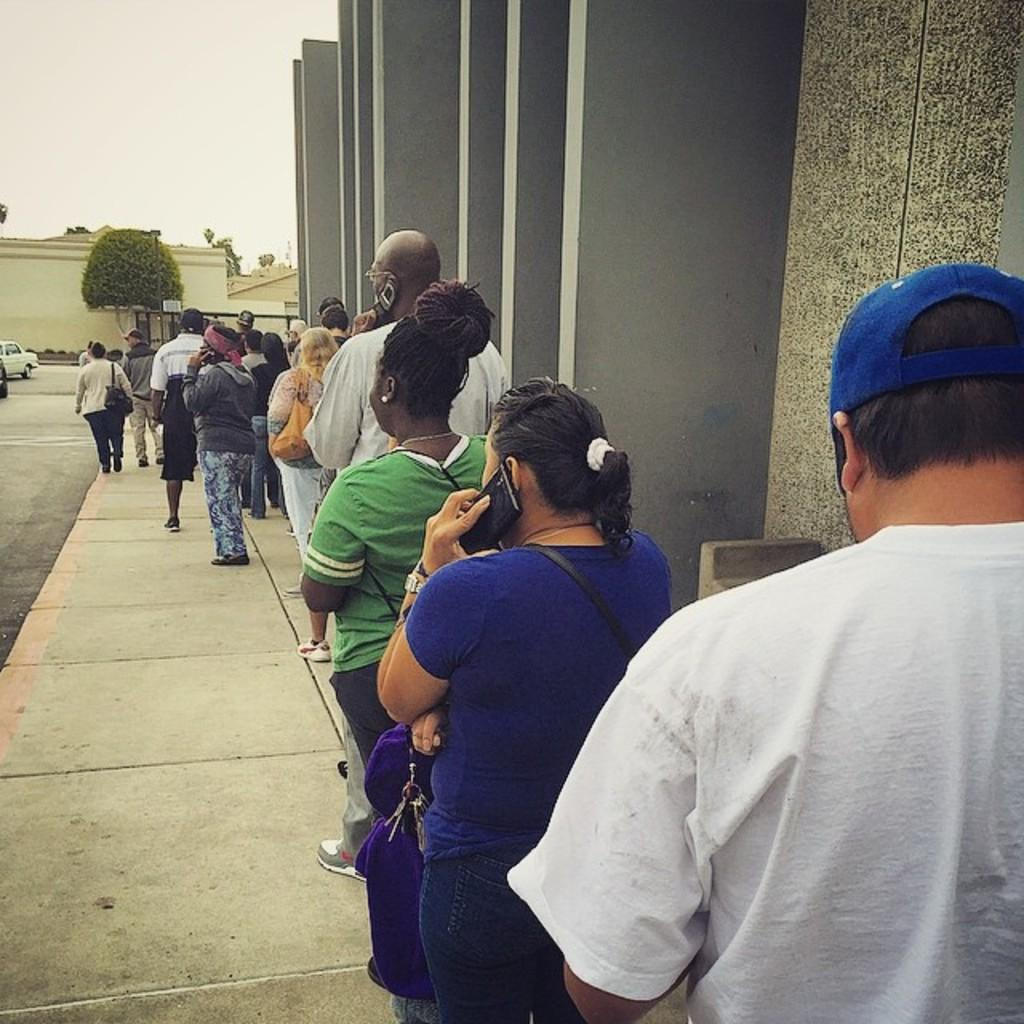What are the main subjects in the center of the image? There are persons standing in the center of the image. What can be seen in the background of the image? There are trees, cars, and a building in the background of the image. What is located on the right side of the image? There is a wall on the right side of the image. What type of pot is being used by the society in the image? There is no pot or society present in the image. What is the reaction of the persons in the image to the event? There is no event or reaction visible in the image; it only shows persons standing in the center. 